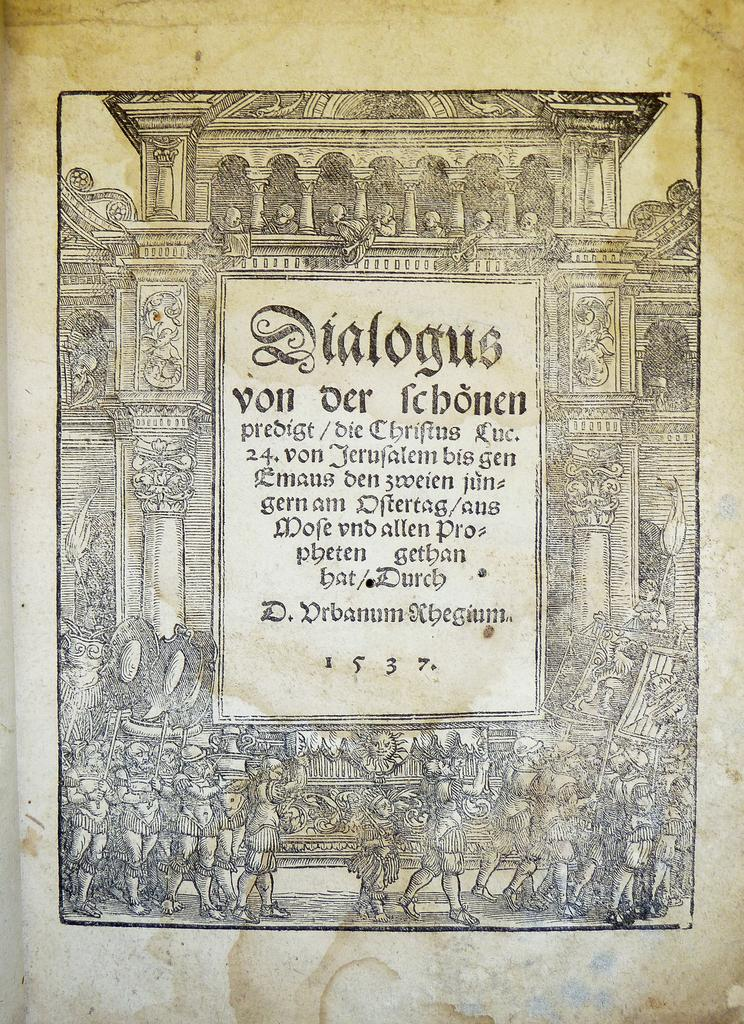What is written on the paper in the image? There is text on a paper in the image. What are the people in the image doing? There is a group of people walking in the image. What are the people holding while walking? The people are holding objects. What can be seen in the background of the image? There is a building in the image. What type of holiday is being celebrated in the image? There is no indication of a holiday being celebrated in the image. Is there a tent visible in the image? There is no tent present in the image. 